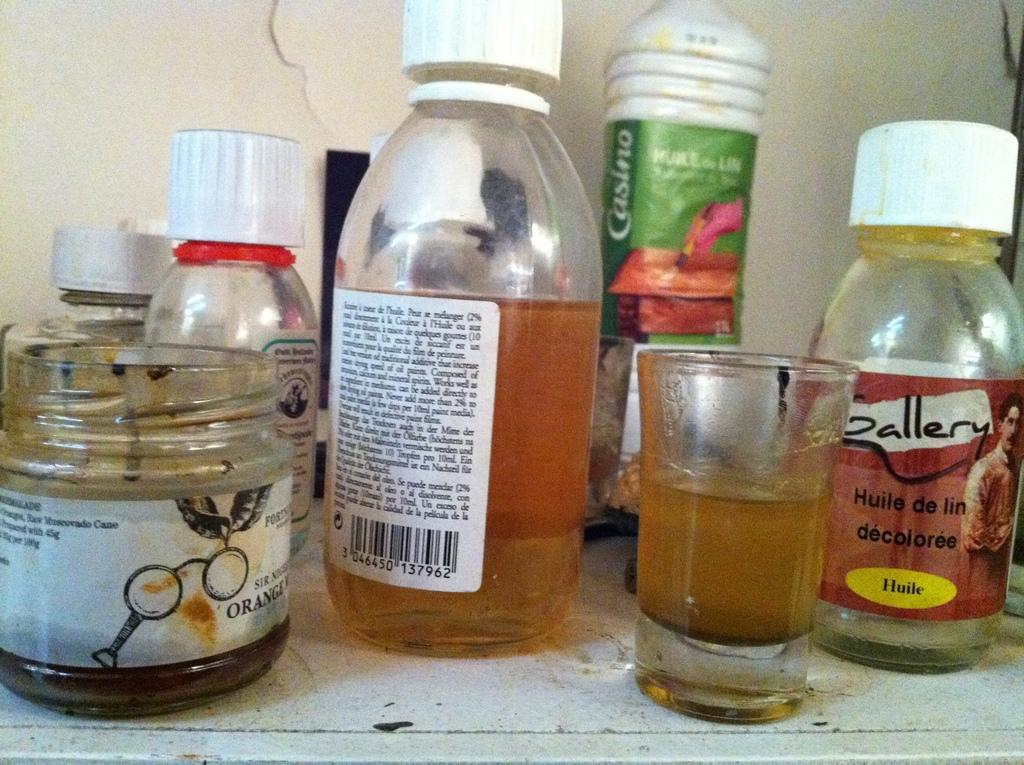<image>
Provide a brief description of the given image. some bottles for Gallery Huile de lin Decoloree and and jars on a table 